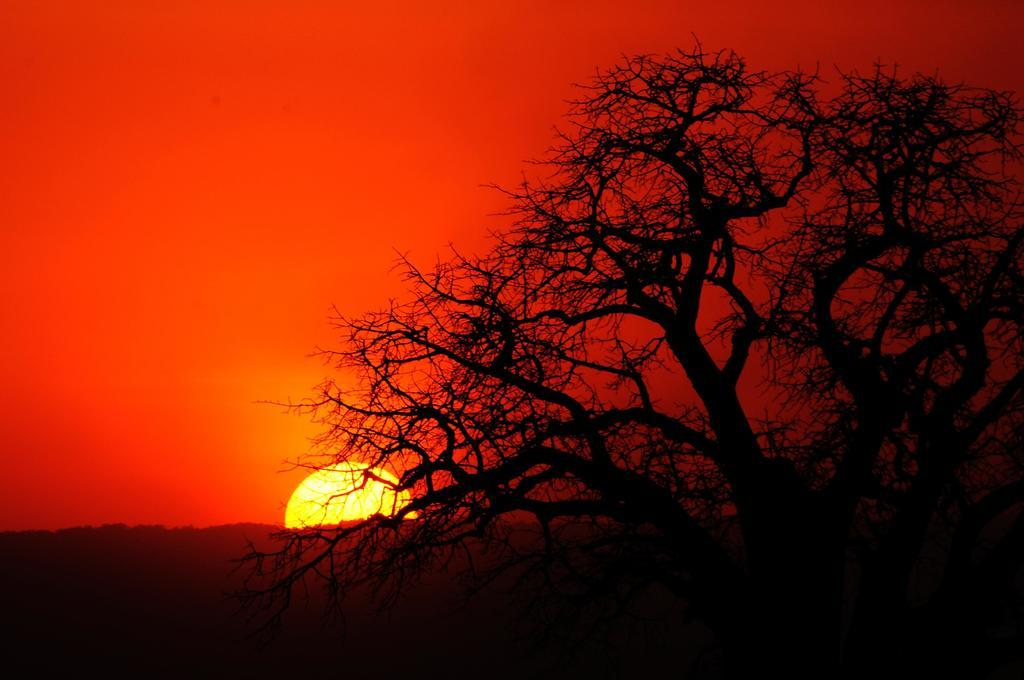What can be seen on the right side of the image? There is a tree without leaves on the right side of the image. What is the color of the sky in the image? The sky appears to be red in color. What celestial body is visible in the image? There is a sun visible in the image. What type of vegetation can be seen in the background area? There are trees in the background area. What type of print can be seen on the donkey in the image? There is no donkey present in the image, so there is no print to observe. What type of meeting is taking place in the image? There is no meeting depicted in the image; it features a tree without leaves, a red sky, a sun, and trees in the background. 